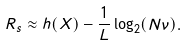Convert formula to latex. <formula><loc_0><loc_0><loc_500><loc_500>R _ { s } \approx h ( X ) - \frac { 1 } L \log _ { 2 } ( N \nu ) .</formula> 